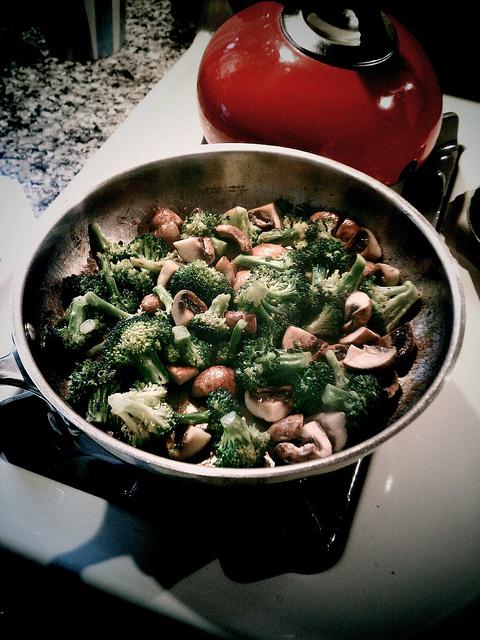What is the green vegetable in the pan?
Be succinct. Broccoli. What color is the kettle?
Write a very short answer. Red. What color is the pan?
Quick response, please. Silver. What is cast?
Answer briefly. Food. What type of mushroom is in the dish?
Quick response, please. Chopped. 